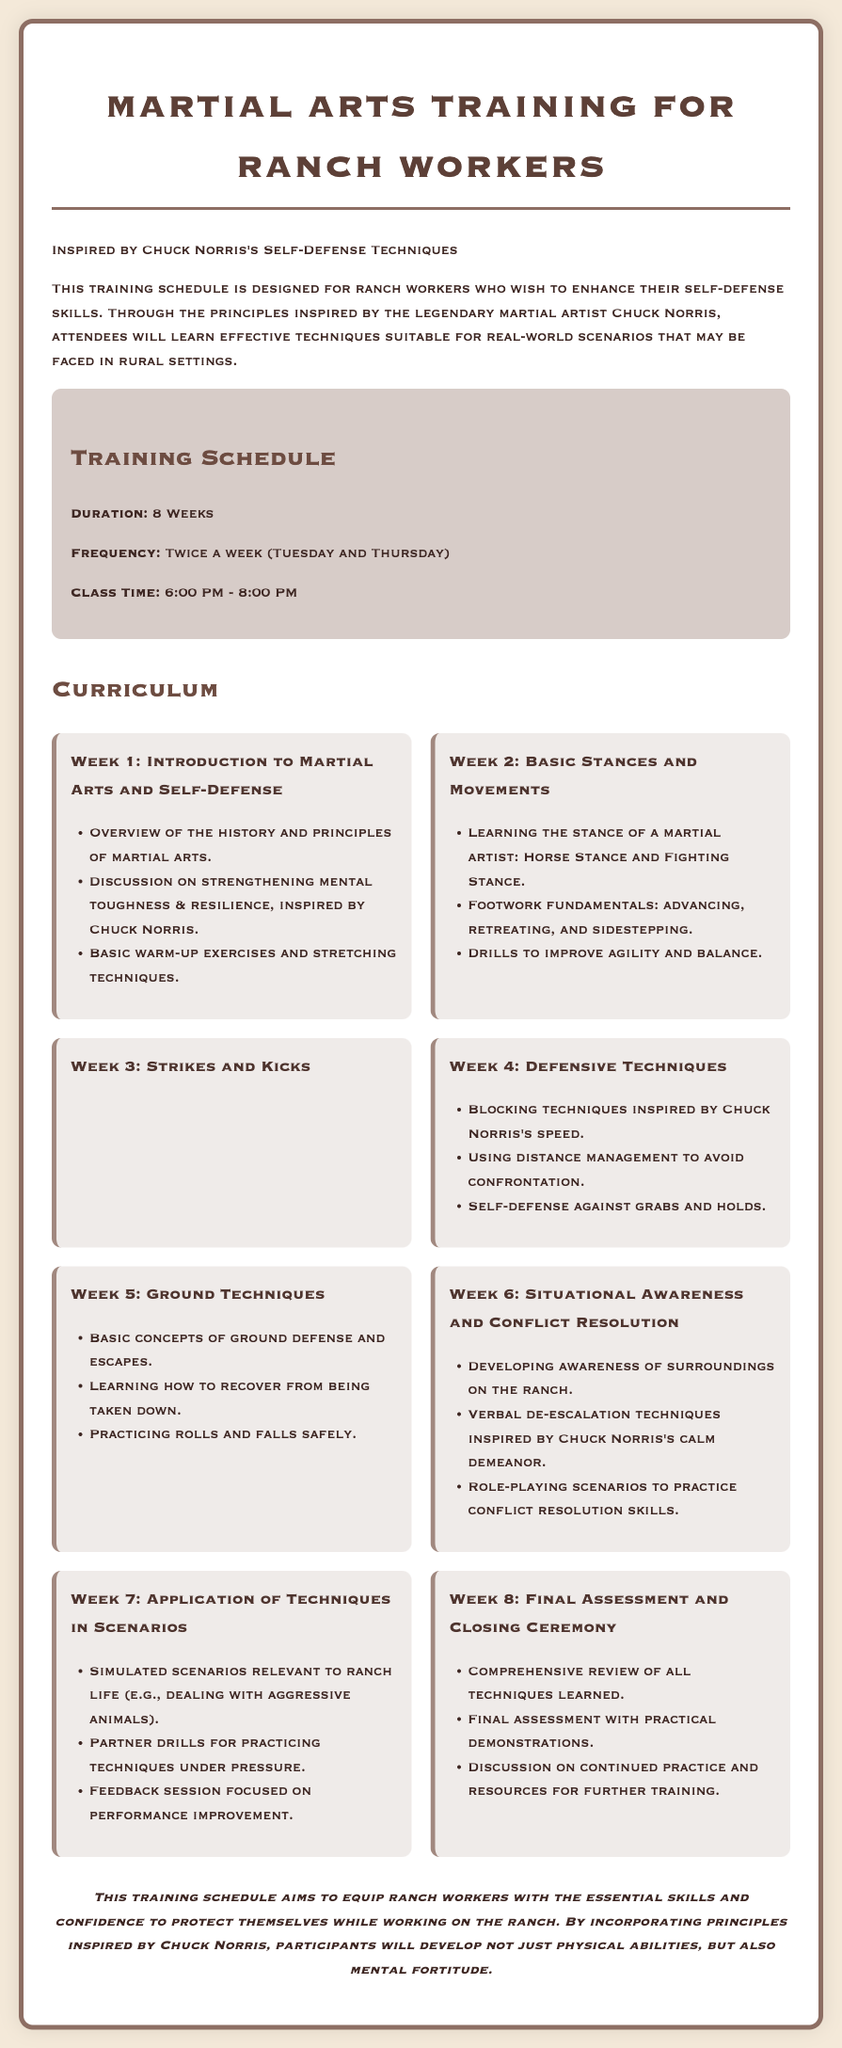What is the duration of the training program? The document specifies that the training program lasts for 8 weeks.
Answer: 8 weeks How often are classes held per week? The document states that classes are conducted twice a week on specific days.
Answer: Twice a week What time do the classes start? The schedule indicates that classes begin at 6:00 PM.
Answer: 6:00 PM Which week covers defensive techniques? Based on the curriculum, the week that focuses on defensive techniques is Week 4.
Answer: Week 4 What principle is emphasized in Week 6 regarding conflict resolution? Week 6 highlights verbal de-escalation techniques inspired by Chuck Norris's calm demeanor.
Answer: Verbal de-escalation techniques What is covered in the final week of the training? The final week, Week 8, involves a comprehensive review and assessment of skills.
Answer: Comprehensive review and assessment Which stance is taught in Week 2? The basic stances and movements include the Horse Stance and Fighting Stance.
Answer: Horse Stance and Fighting Stance What aspect of ranch worker safety is the training designed to enhance? The training aims to enhance self-defense skills among ranch workers.
Answer: Self-defense skills 